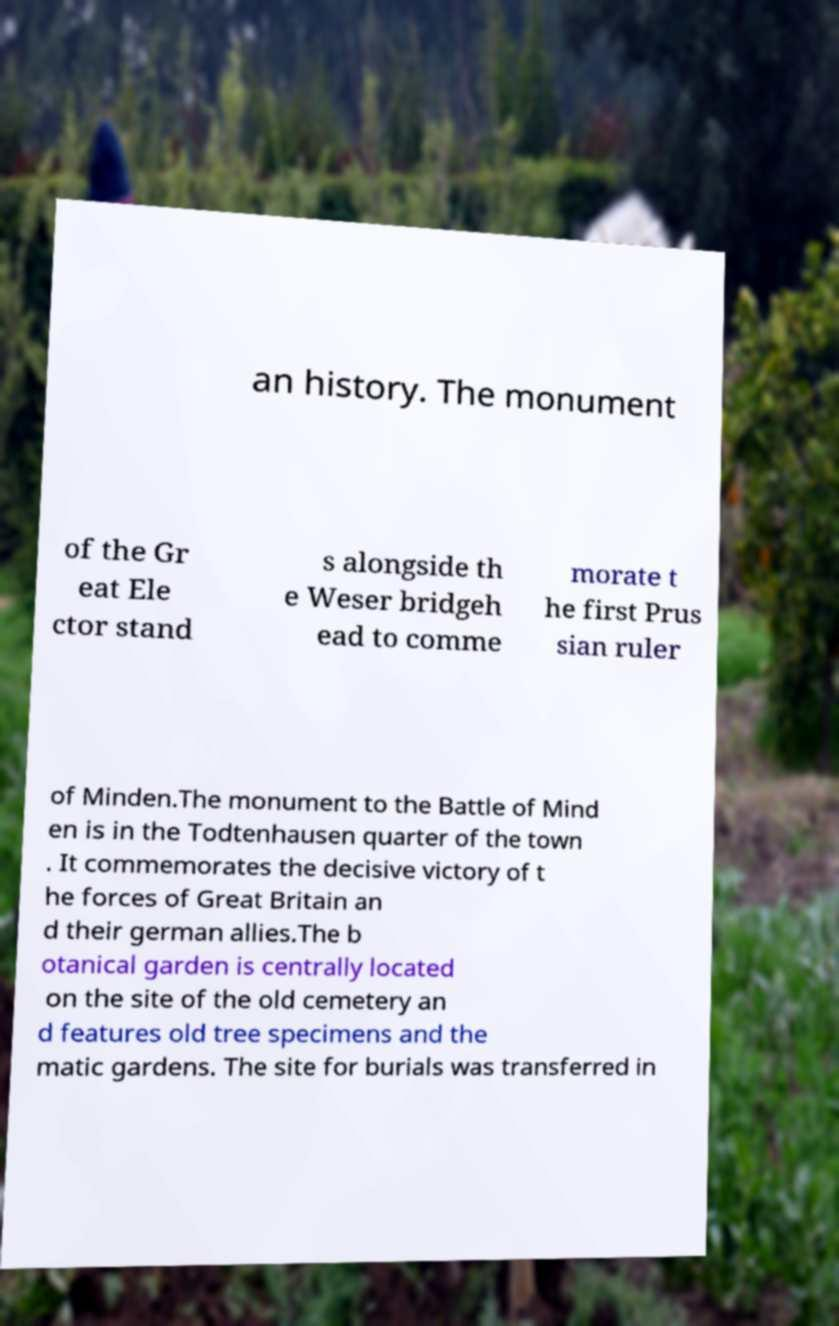Could you assist in decoding the text presented in this image and type it out clearly? an history. The monument of the Gr eat Ele ctor stand s alongside th e Weser bridgeh ead to comme morate t he first Prus sian ruler of Minden.The monument to the Battle of Mind en is in the Todtenhausen quarter of the town . It commemorates the decisive victory of t he forces of Great Britain an d their german allies.The b otanical garden is centrally located on the site of the old cemetery an d features old tree specimens and the matic gardens. The site for burials was transferred in 